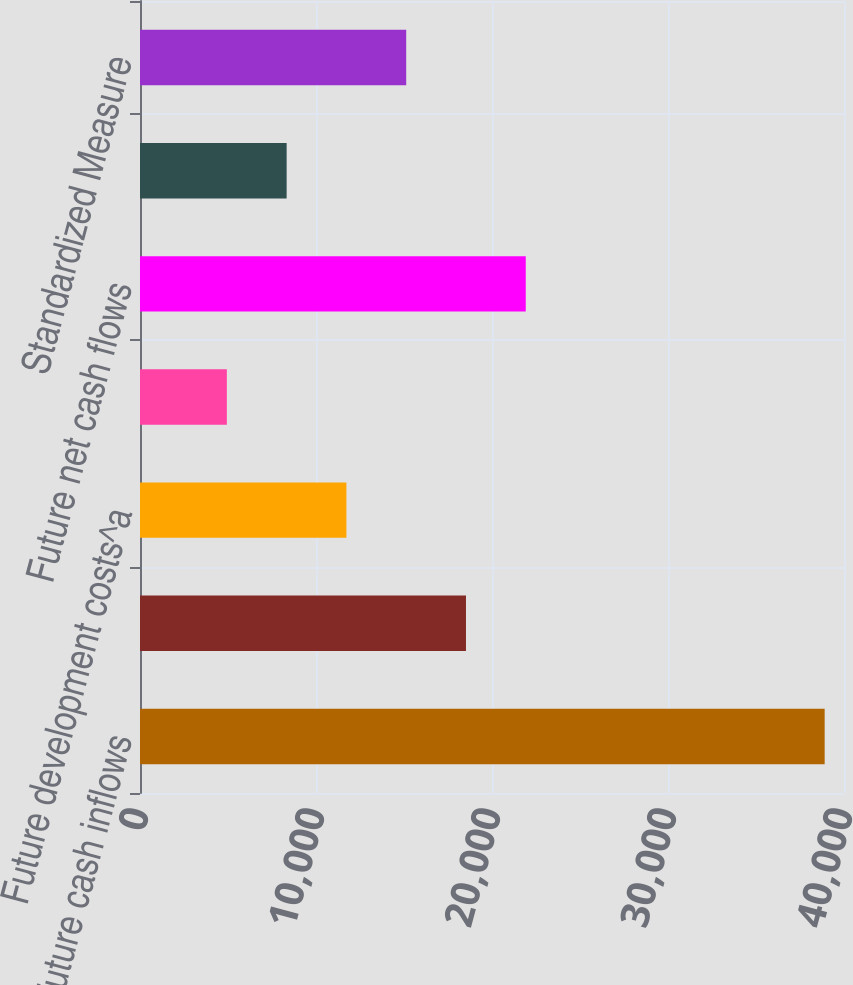Convert chart. <chart><loc_0><loc_0><loc_500><loc_500><bar_chart><fcel>Future cash inflows<fcel>Future production expense<fcel>Future development costs^a<fcel>Future income tax expense<fcel>Future net cash flows<fcel>Discounted at 10 per year<fcel>Standardized Measure<nl><fcel>38901<fcel>18521.4<fcel>11728.2<fcel>4935<fcel>21918<fcel>8331.6<fcel>15124.8<nl></chart> 